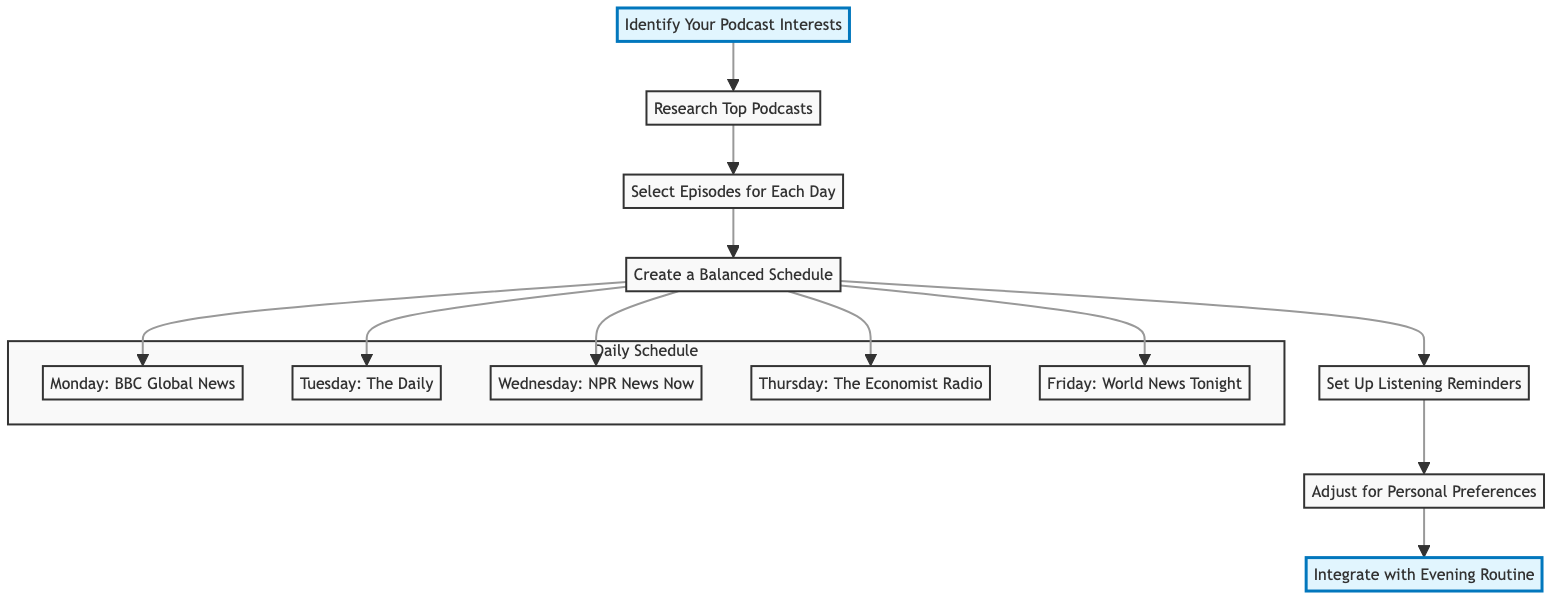What is the first step in creating a personalized podcast playlist? The first step as per the diagram is "Identify Your Podcast Interests". This is derived from the starting point of the flowchart, which highlights the initial action to be taken when creating the playlist.
Answer: Identify Your Podcast Interests How many total steps are there in the flowchart? Upon reviewing the diagram, there are a total of seven steps listed sequentially, from identifying interests to integrating with the evening routine.
Answer: 7 Which step involves setting up reminders? The step that specifically mentions reminders is "Set Up Listening Reminders". This is the fifth step in the flowchart, identified by the label linked to this action.
Answer: Set Up Listening Reminders What is the example podcast for Thursday? The diagram indicates "The Economist Radio" as the example podcast scheduled for Thursday. This is part of the daily schedule derived from the fourth step.
Answer: The Economist Radio What action comes after selecting episodes? Following the "Select Episodes for Each Day" step, the next action highlighted in the flowchart is "Create a Balanced Schedule". This flows sequentially from one step to the next.
Answer: Create a Balanced Schedule Which source is suggested for researching top podcasts? The diagram lists "Apple Podcasts, Spotify, Google Podcasts" as sources for researching top podcasts. This information is found in the second step and indicates the platforms to consider.
Answer: Apple Podcasts, Spotify, Google Podcasts What adjustment is recommended after the first week? The diagram suggests reviewing your experience and adjusting your approach by changing podcast selection, reordering the episode schedule, or adjusting listening times as intended adjustments after the first week.
Answer: Change podcast selection How can listening be integrated into the evening routine? The flowchart suggests integrating listening with the evening routine by actions such as listening while drinking tea or during a light stretching session. These examples make up the last step in the flowchart.
Answer: Listen while drinking tea 